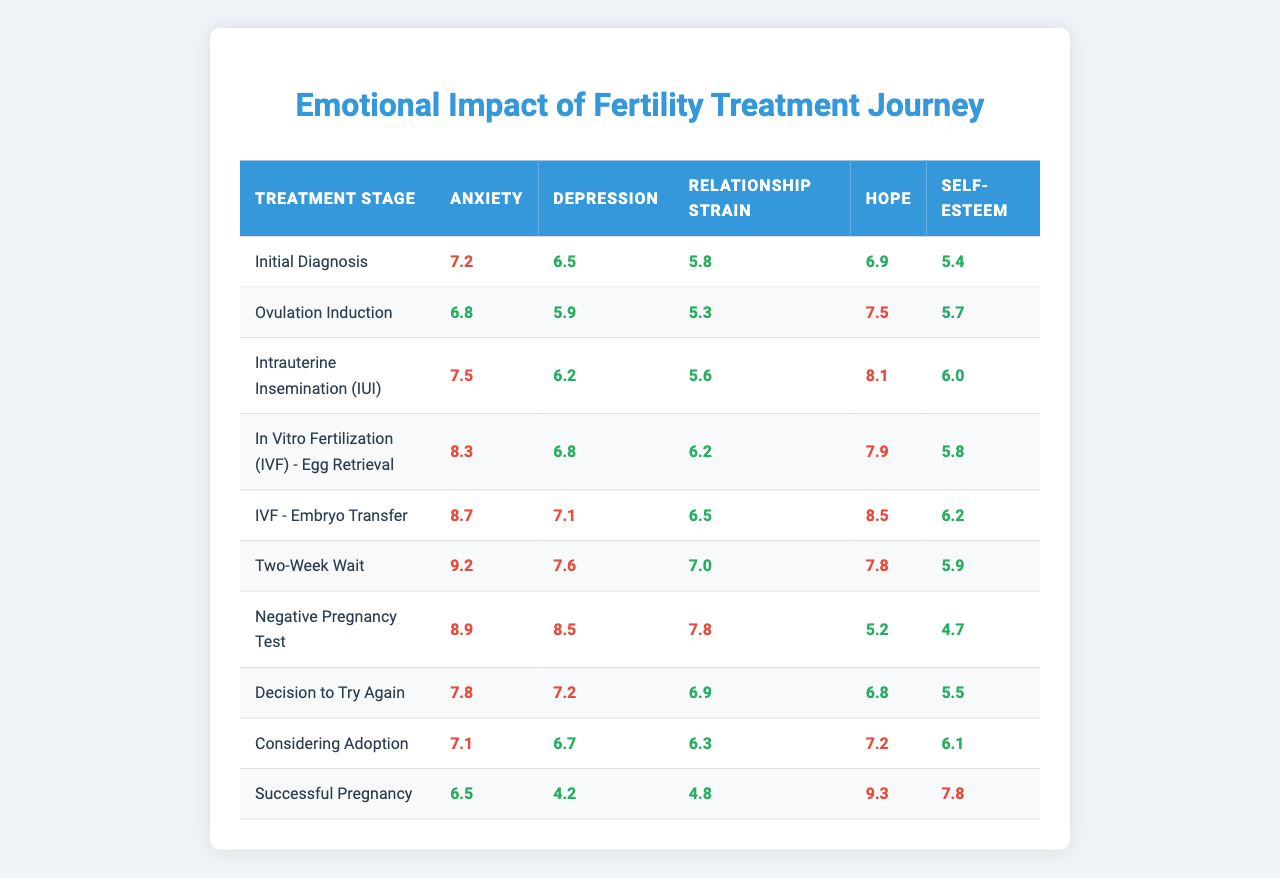What is the anxiety score during the Two-Week Wait stage? The anxiety score listed for the Two-Week Wait stage in the table is 9.2.
Answer: 9.2 Which treatment stage has the highest depression score? Looking at the depression scores for each stage, the highest score is 8.5 during the Negative Pregnancy Test stage.
Answer: 8.5 What is the average relationship strain score across all treatment stages? To calculate the average relationship strain score, sum all the scores (5.8 + 5.3 + 5.6 + 6.2 + 6.5 + 7.0 + 7.8 + 6.9 + 6.3 + 4.8) =  57.1, then divide by the total number of stages (10), leading to an average of 57.1/10 = 5.71.
Answer: 5.71 Is the self-esteem score highest in the Successful Pregnancy stage? Comparing the self-esteem scores, the highest score is 7.8 in the Successful Pregnancy stage, confirming it as the highest.
Answer: Yes What is the difference in hope scores between the initial diagnosis and the Negative Pregnancy Test? The hope score during the Initial Diagnosis is 6.9, while it's 5.2 during the Negative Pregnancy Test. The difference is 6.9 - 5.2 = 1.7.
Answer: 1.7 How does the anxiety score change from the Ovulation Induction stage to the IVF - Embryo Transfer stage? The anxiety score during Ovulation Induction is 6.8, and during IVF - Embryo Transfer, it is 8.7. The change is 8.7 - 6.8 = 1.9, indicating an increase.
Answer: Increased by 1.9 What treatment stage presents the lowest self-esteem score? The lowest self-esteem score is recorded during the Negative Pregnancy Test stage, which has a score of 4.7.
Answer: 4.7 Does the hope score consistently increase throughout the treatment stages? By examining the hope scores, we can see they fluctuate: 6.9, 7.5, 8.1, 7.9, 8.5, 7.8, 5.2, 6.8, 7.2, 9.3. Therefore, it does not consistently increase.
Answer: No Which treatment stage exhibits the highest levels of anxiety, depression, and relationship strain? The IVF - Embryo Transfer stage shows anxiety at 8.7, depression at 7.1, and relationship strain at 6.5, indicating significant emotional impact.
Answer: IVF - Embryo Transfer For couples considering adoption, how does their emotional impact compare to those deciding to try again? The anxiety score for Considering Adoption is 7.1, while for Decision to Try Again, it is 7.8. The depression score is higher in the latter (7.2 vs 6.7), indicating greater emotional impact when deciding to try again.
Answer: Higher emotional impact when trying again 